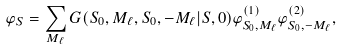<formula> <loc_0><loc_0><loc_500><loc_500>\varphi _ { S } = \sum _ { M _ { \ell } } G ( S _ { 0 } , M _ { \ell } , S _ { 0 } , - M _ { \ell } | S , 0 ) \varphi _ { S _ { 0 } , M _ { \ell } } ^ { ( 1 ) } \varphi _ { S _ { 0 } , - M _ { \ell } } ^ { ( 2 ) } ,</formula> 